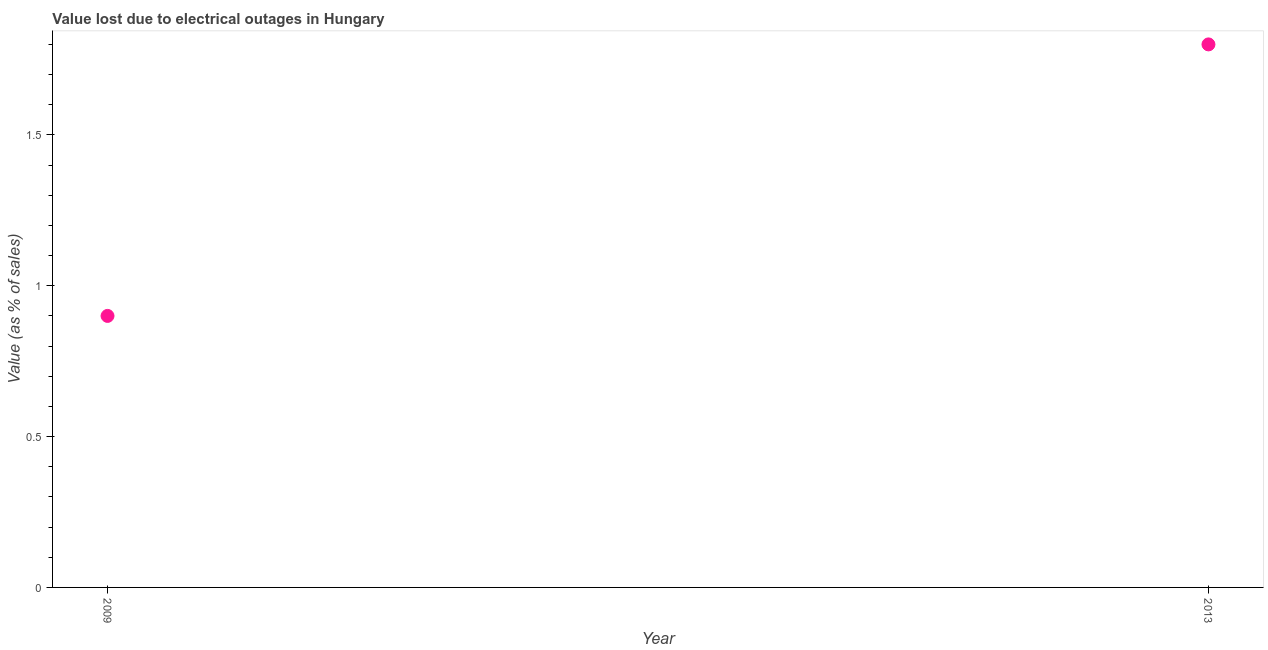Across all years, what is the minimum value lost due to electrical outages?
Provide a short and direct response. 0.9. In which year was the value lost due to electrical outages minimum?
Give a very brief answer. 2009. What is the sum of the value lost due to electrical outages?
Your answer should be very brief. 2.7. What is the difference between the value lost due to electrical outages in 2009 and 2013?
Your answer should be compact. -0.9. What is the average value lost due to electrical outages per year?
Offer a terse response. 1.35. What is the median value lost due to electrical outages?
Provide a short and direct response. 1.35. In how many years, is the value lost due to electrical outages greater than 1.1 %?
Provide a succinct answer. 1. Do a majority of the years between 2009 and 2013 (inclusive) have value lost due to electrical outages greater than 0.8 %?
Provide a succinct answer. Yes. Is the value lost due to electrical outages in 2009 less than that in 2013?
Offer a terse response. Yes. In how many years, is the value lost due to electrical outages greater than the average value lost due to electrical outages taken over all years?
Your response must be concise. 1. Does the value lost due to electrical outages monotonically increase over the years?
Offer a very short reply. Yes. How many dotlines are there?
Ensure brevity in your answer.  1. What is the difference between two consecutive major ticks on the Y-axis?
Keep it short and to the point. 0.5. What is the title of the graph?
Ensure brevity in your answer.  Value lost due to electrical outages in Hungary. What is the label or title of the Y-axis?
Offer a terse response. Value (as % of sales). What is the Value (as % of sales) in 2009?
Your answer should be compact. 0.9. What is the ratio of the Value (as % of sales) in 2009 to that in 2013?
Your answer should be very brief. 0.5. 